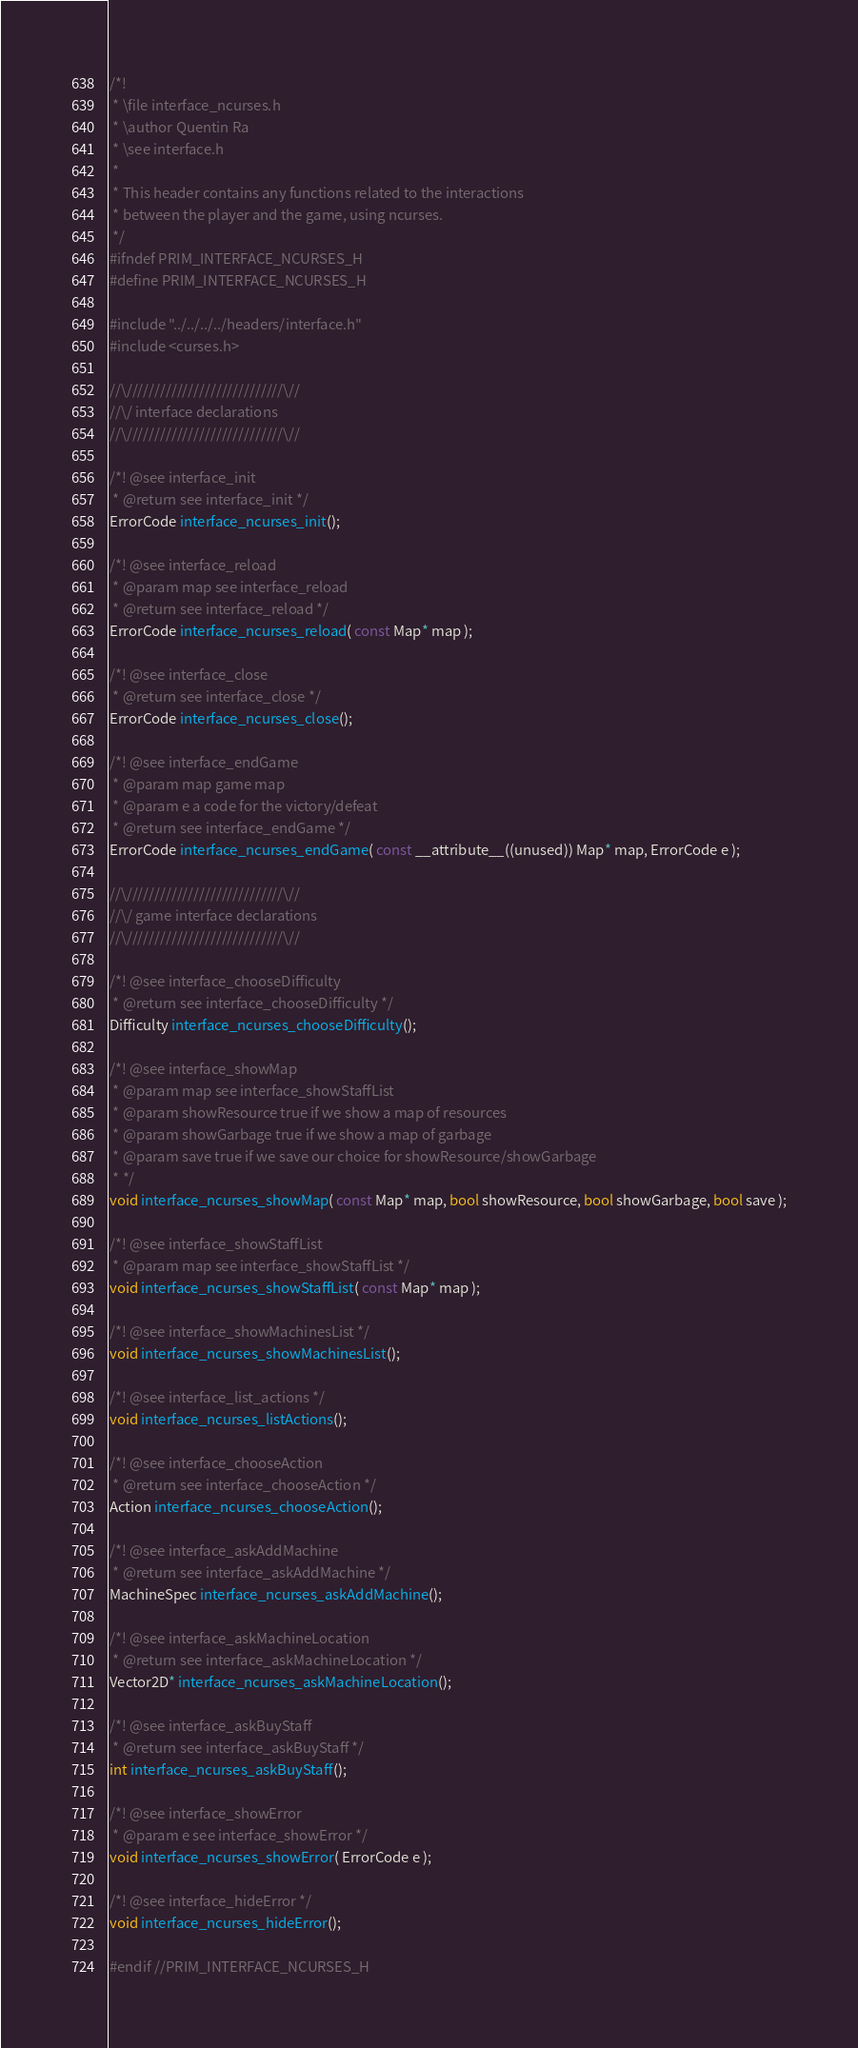<code> <loc_0><loc_0><loc_500><loc_500><_C_>/*!
 * \file interface_ncurses.h
 * \author Quentin Ra
 * \see interface.h
 *
 * This header contains any functions related to the interactions
 * between the player and the game, using ncurses.
 */
#ifndef PRIM_INTERFACE_NCURSES_H
#define PRIM_INTERFACE_NCURSES_H

#include "../../../../headers/interface.h"
#include <curses.h>

//\////////////////////////////\//
//\/ interface declarations
//\////////////////////////////\//

/*! @see interface_init
 * @return see interface_init */
ErrorCode interface_ncurses_init();

/*! @see interface_reload
 * @param map see interface_reload
 * @return see interface_reload */
ErrorCode interface_ncurses_reload( const Map* map );

/*! @see interface_close
 * @return see interface_close */
ErrorCode interface_ncurses_close();

/*! @see interface_endGame
 * @param map game map
 * @param e a code for the victory/defeat
 * @return see interface_endGame */
ErrorCode interface_ncurses_endGame( const __attribute__((unused)) Map* map, ErrorCode e );

//\////////////////////////////\//
//\/ game interface declarations
//\////////////////////////////\//

/*! @see interface_chooseDifficulty
 * @return see interface_chooseDifficulty */
Difficulty interface_ncurses_chooseDifficulty();

/*! @see interface_showMap
 * @param map see interface_showStaffList
 * @param showResource true if we show a map of resources
 * @param showGarbage true if we show a map of garbage
 * @param save true if we save our choice for showResource/showGarbage
 * */
void interface_ncurses_showMap( const Map* map, bool showResource, bool showGarbage, bool save );

/*! @see interface_showStaffList
 * @param map see interface_showStaffList */
void interface_ncurses_showStaffList( const Map* map );

/*! @see interface_showMachinesList */
void interface_ncurses_showMachinesList();

/*! @see interface_list_actions */
void interface_ncurses_listActions();

/*! @see interface_chooseAction
 * @return see interface_chooseAction */
Action interface_ncurses_chooseAction();

/*! @see interface_askAddMachine
 * @return see interface_askAddMachine */
MachineSpec interface_ncurses_askAddMachine();

/*! @see interface_askMachineLocation
 * @return see interface_askMachineLocation */
Vector2D* interface_ncurses_askMachineLocation();

/*! @see interface_askBuyStaff
 * @return see interface_askBuyStaff */
int interface_ncurses_askBuyStaff();

/*! @see interface_showError
 * @param e see interface_showError */
void interface_ncurses_showError( ErrorCode e );

/*! @see interface_hideError */
void interface_ncurses_hideError();

#endif //PRIM_INTERFACE_NCURSES_H
</code> 